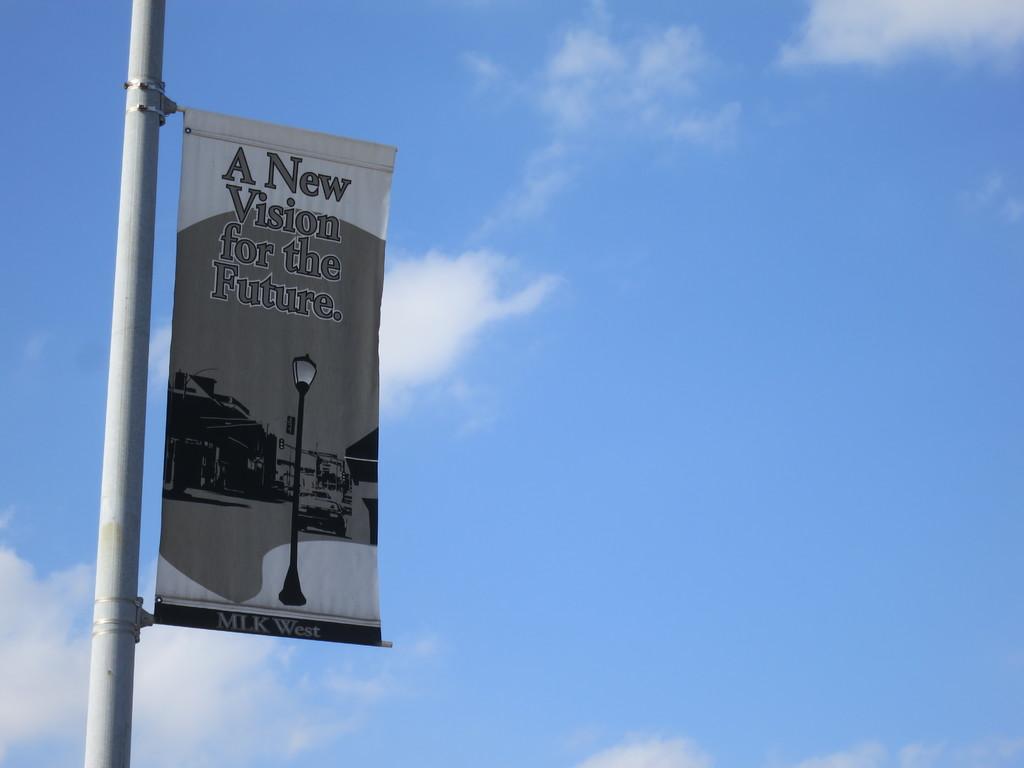What is the name on the flag?
Ensure brevity in your answer.  Mlk west. 